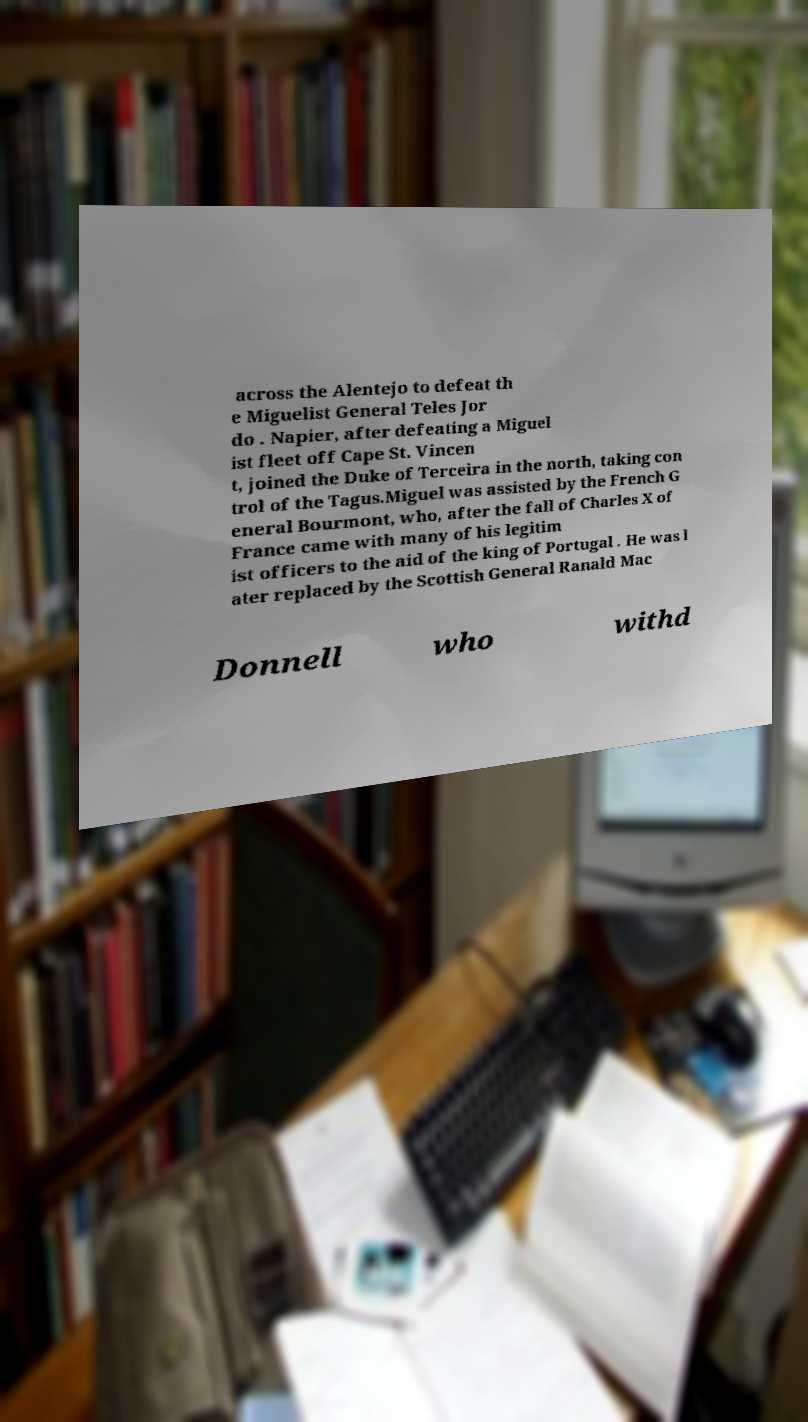Please identify and transcribe the text found in this image. across the Alentejo to defeat th e Miguelist General Teles Jor do . Napier, after defeating a Miguel ist fleet off Cape St. Vincen t, joined the Duke of Terceira in the north, taking con trol of the Tagus.Miguel was assisted by the French G eneral Bourmont, who, after the fall of Charles X of France came with many of his legitim ist officers to the aid of the king of Portugal . He was l ater replaced by the Scottish General Ranald Mac Donnell who withd 